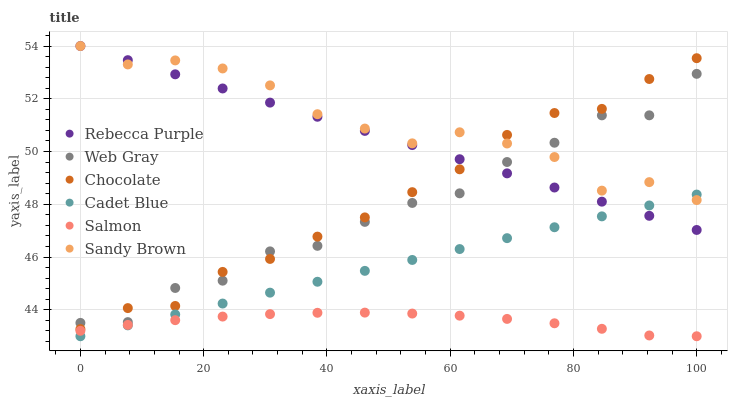Does Salmon have the minimum area under the curve?
Answer yes or no. Yes. Does Sandy Brown have the maximum area under the curve?
Answer yes or no. Yes. Does Chocolate have the minimum area under the curve?
Answer yes or no. No. Does Chocolate have the maximum area under the curve?
Answer yes or no. No. Is Rebecca Purple the smoothest?
Answer yes or no. Yes. Is Web Gray the roughest?
Answer yes or no. Yes. Is Salmon the smoothest?
Answer yes or no. No. Is Salmon the roughest?
Answer yes or no. No. Does Cadet Blue have the lowest value?
Answer yes or no. Yes. Does Chocolate have the lowest value?
Answer yes or no. No. Does Sandy Brown have the highest value?
Answer yes or no. Yes. Does Chocolate have the highest value?
Answer yes or no. No. Is Salmon less than Web Gray?
Answer yes or no. Yes. Is Web Gray greater than Salmon?
Answer yes or no. Yes. Does Cadet Blue intersect Salmon?
Answer yes or no. Yes. Is Cadet Blue less than Salmon?
Answer yes or no. No. Is Cadet Blue greater than Salmon?
Answer yes or no. No. Does Salmon intersect Web Gray?
Answer yes or no. No. 